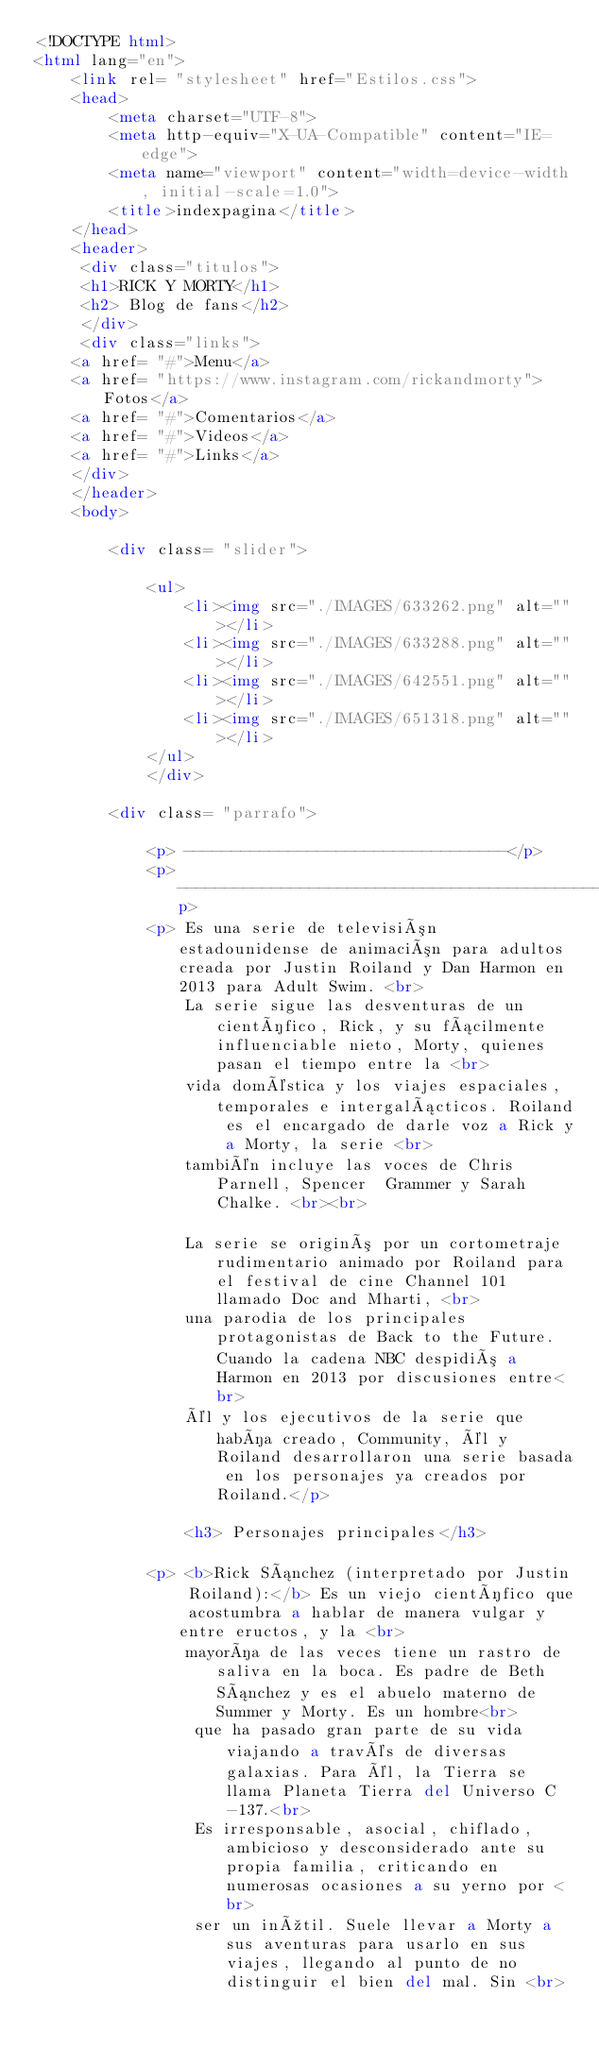<code> <loc_0><loc_0><loc_500><loc_500><_HTML_><!DOCTYPE html>
<html lang="en">
    <link rel= "stylesheet" href="Estilos.css">
    <head>
        <meta charset="UTF-8">
        <meta http-equiv="X-UA-Compatible" content="IE=edge">
        <meta name="viewport" content="width=device-width, initial-scale=1.0">
        <title>indexpagina</title>
    </head>
    <header>
     <div class="titulos">
     <h1>RICK Y MORTY</h1>
     <h2> Blog de fans</h2>
     </div>
     <div class="links">
    <a href= "#">Menu</a>
    <a href= "https://www.instagram.com/rickandmorty">Fotos</a>
    <a href= "#">Comentarios</a>
    <a href= "#">Videos</a>
    <a href= "#">Links</a>
    </div>
    </header>
    <body>
  
        <div class= "slider">

            <ul>
                <li><img src="./IMAGES/633262.png" alt=""></li>
                <li><img src="./IMAGES/633288.png" alt=""></li>
                <li><img src="./IMAGES/642551.png" alt=""></li>
                <li><img src="./IMAGES/651318.png" alt=""></li>
            </ul>
            </div>
      
        <div class= "parrafo">

            <p> ----------------------------------</p>
            <p> -----------------------------------------------------------------------------------------------------------------------------------</p>
            <p> Es una serie de televisión estadounidense de animación para adultos creada por Justin Roiland y Dan Harmon en 2013 para Adult Swim. <br>
                La serie sigue las desventuras de un científico, Rick, y su fácilmente influenciable nieto, Morty, quienes pasan el tiempo entre la <br>
                vida doméstica y los viajes espaciales, temporales e intergalácticos. Roiland es el encargado de darle voz a Rick y a Morty, la serie <br> 
                también incluye las voces de Chris Parnell, Spencer  Grammer y Sarah Chalke. <br><br>

                La serie se originó por un cortometraje rudimentario animado por Roiland para el festival de cine Channel 101 llamado Doc and Mharti, <br>
                una parodia de los principales protagonistas de Back to the Future. Cuando la cadena NBC despidió a Harmon en 2013 por discusiones entre<br>
                él y los ejecutivos de la serie que había creado, Community, él y Roiland desarrollaron una serie basada en los personajes ya creados por Roiland.</p>

                <h3> Personajes principales</h3>

            <p> <b>Rick Sánchez (interpretado por Justin Roiland):</b> Es un viejo científico que acostumbra a hablar de manera vulgar y entre eructos, y la <br>
                mayoría de las veces tiene un rastro de saliva en la boca. Es padre de Beth Sánchez y es el abuelo materno de Summer y Morty. Es un hombre<br>
                 que ha pasado gran parte de su vida viajando a través de diversas galaxias. Para él, la Tierra se llama Planeta Tierra del Universo C-137.<br> 
                 Es irresponsable, asocial, chiflado, ambicioso y desconsiderado ante su propia familia, criticando en numerosas ocasiones a su yerno por <br>
                 ser un inútil. Suele llevar a Morty a sus aventuras para usarlo en sus viajes, llegando al punto de no distinguir el bien del mal. Sin <br></code> 